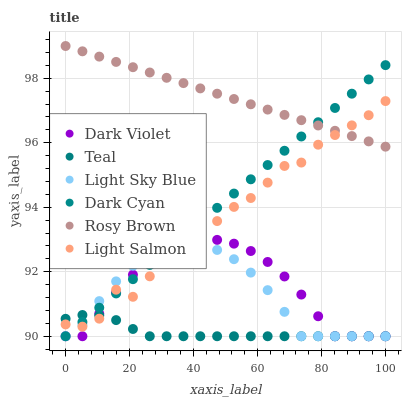Does Teal have the minimum area under the curve?
Answer yes or no. Yes. Does Rosy Brown have the maximum area under the curve?
Answer yes or no. Yes. Does Dark Violet have the minimum area under the curve?
Answer yes or no. No. Does Dark Violet have the maximum area under the curve?
Answer yes or no. No. Is Dark Cyan the smoothest?
Answer yes or no. Yes. Is Light Salmon the roughest?
Answer yes or no. Yes. Is Rosy Brown the smoothest?
Answer yes or no. No. Is Rosy Brown the roughest?
Answer yes or no. No. Does Dark Violet have the lowest value?
Answer yes or no. Yes. Does Rosy Brown have the lowest value?
Answer yes or no. No. Does Rosy Brown have the highest value?
Answer yes or no. Yes. Does Dark Violet have the highest value?
Answer yes or no. No. Is Dark Violet less than Rosy Brown?
Answer yes or no. Yes. Is Rosy Brown greater than Teal?
Answer yes or no. Yes. Does Light Sky Blue intersect Dark Cyan?
Answer yes or no. Yes. Is Light Sky Blue less than Dark Cyan?
Answer yes or no. No. Is Light Sky Blue greater than Dark Cyan?
Answer yes or no. No. Does Dark Violet intersect Rosy Brown?
Answer yes or no. No. 